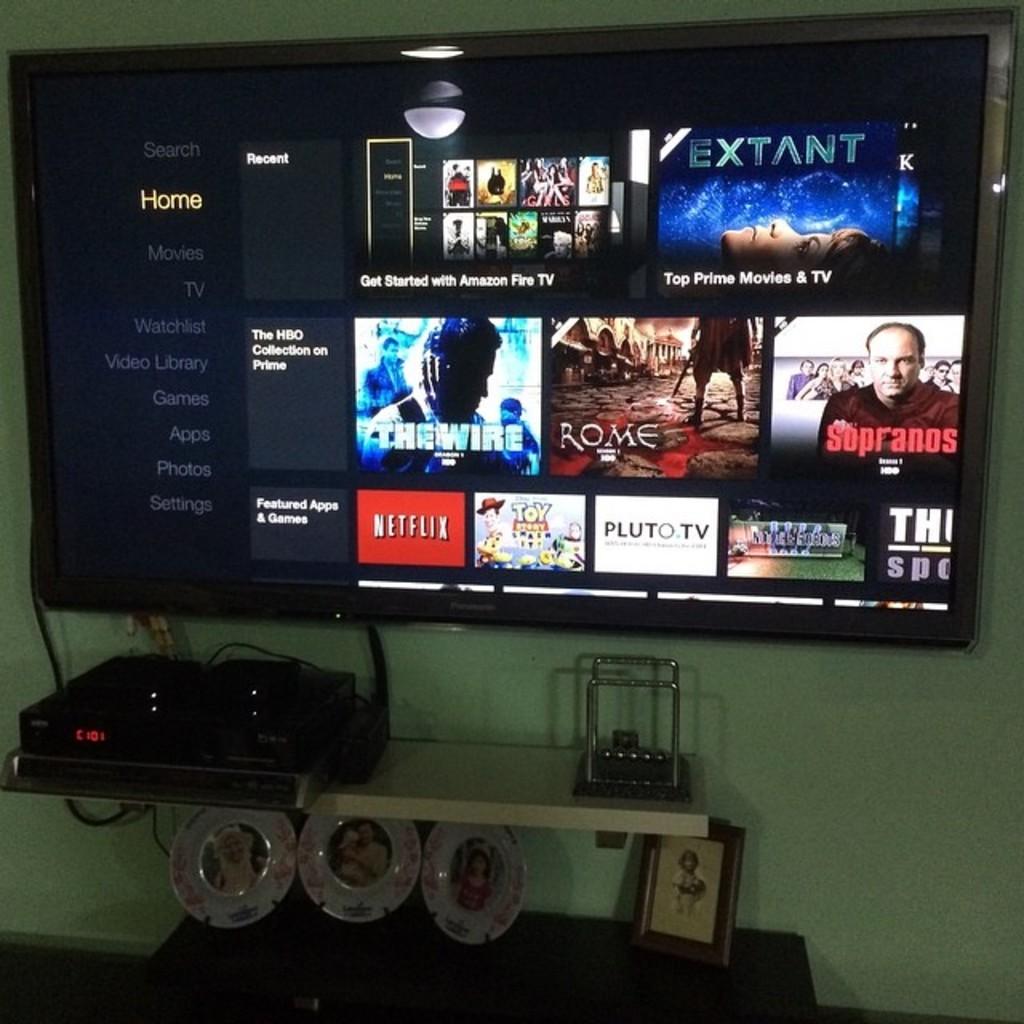What word is highlighted on left side of screen?
Offer a very short reply. Home. This is led tv?
Your answer should be very brief. Unanswerable. 